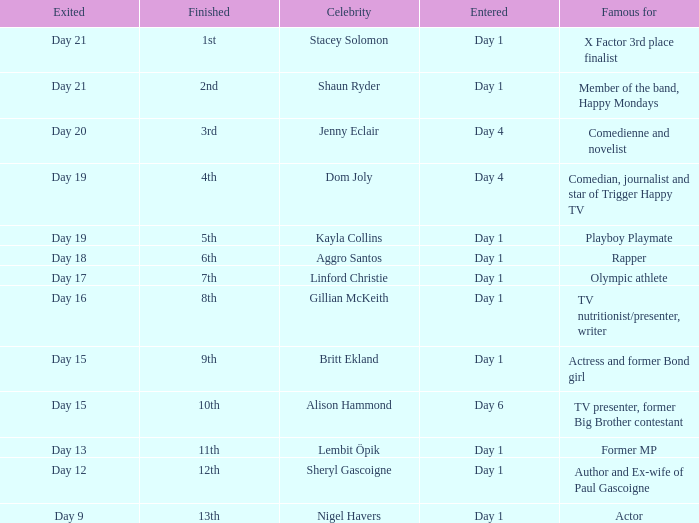What was Dom Joly famous for? Comedian, journalist and star of Trigger Happy TV. 